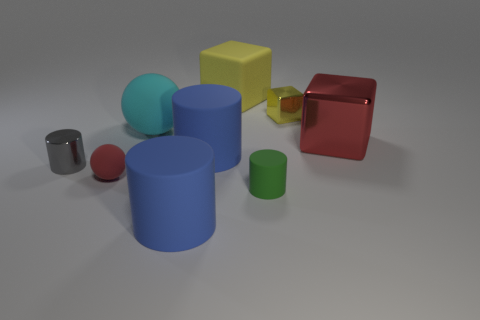How many small things are either gray metal objects or red matte things?
Give a very brief answer. 2. Does the large yellow rubber object have the same shape as the red matte object?
Offer a terse response. No. How many cubes are both right of the small green matte thing and behind the cyan rubber ball?
Offer a terse response. 1. Are there any other things that are the same color as the small ball?
Keep it short and to the point. Yes. The green object that is the same material as the large yellow block is what shape?
Offer a terse response. Cylinder. Do the gray shiny thing and the red matte thing have the same size?
Make the answer very short. Yes. Is the big block in front of the large matte cube made of the same material as the cyan sphere?
Keep it short and to the point. No. Is there any other thing that is made of the same material as the tiny sphere?
Make the answer very short. Yes. There is a blue matte cylinder that is right of the big rubber cylinder in front of the green cylinder; how many red things are on the left side of it?
Your answer should be very brief. 1. There is a tiny metal object in front of the cyan ball; is its shape the same as the cyan rubber thing?
Provide a succinct answer. No. 